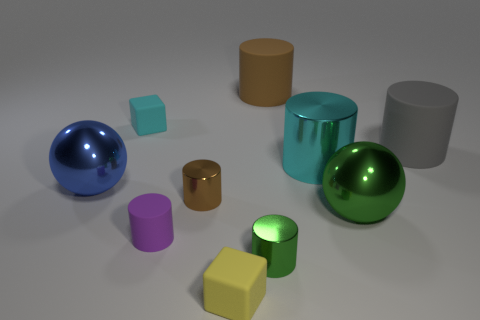Subtract 1 cylinders. How many cylinders are left? 5 Subtract all cyan cylinders. How many cylinders are left? 5 Subtract all large brown rubber cylinders. How many cylinders are left? 5 Subtract all green cylinders. Subtract all brown spheres. How many cylinders are left? 5 Subtract all spheres. How many objects are left? 8 Subtract all tiny purple shiny spheres. Subtract all small cyan cubes. How many objects are left? 9 Add 6 big cyan objects. How many big cyan objects are left? 7 Add 1 tiny cyan matte objects. How many tiny cyan matte objects exist? 2 Subtract 0 red blocks. How many objects are left? 10 